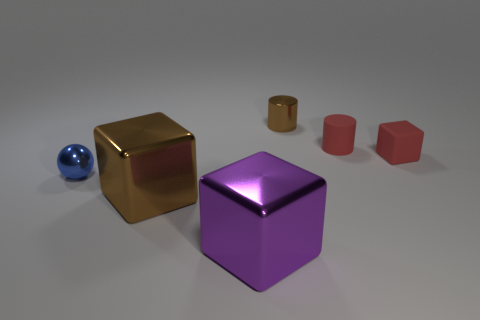The metallic thing behind the small blue thing that is behind the brown object that is in front of the small red rubber block is what color?
Offer a very short reply. Brown. There is a brown object on the left side of the tiny brown object; is its shape the same as the large purple thing?
Your answer should be very brief. Yes. How many large brown metallic objects are there?
Provide a succinct answer. 1. What number of gray blocks are the same size as the blue metal thing?
Offer a very short reply. 0. What material is the red cube?
Ensure brevity in your answer.  Rubber. There is a tiny metallic cylinder; does it have the same color as the shiny block left of the large purple cube?
Keep it short and to the point. Yes. There is a thing that is both on the left side of the large purple thing and to the right of the blue object; how big is it?
Keep it short and to the point. Large. The brown thing that is made of the same material as the brown cylinder is what shape?
Your response must be concise. Cube. Does the big brown thing have the same material as the brown object that is behind the small red rubber cube?
Keep it short and to the point. Yes. There is a tiny metal thing behind the small blue object; are there any brown shiny objects to the left of it?
Offer a very short reply. Yes. 